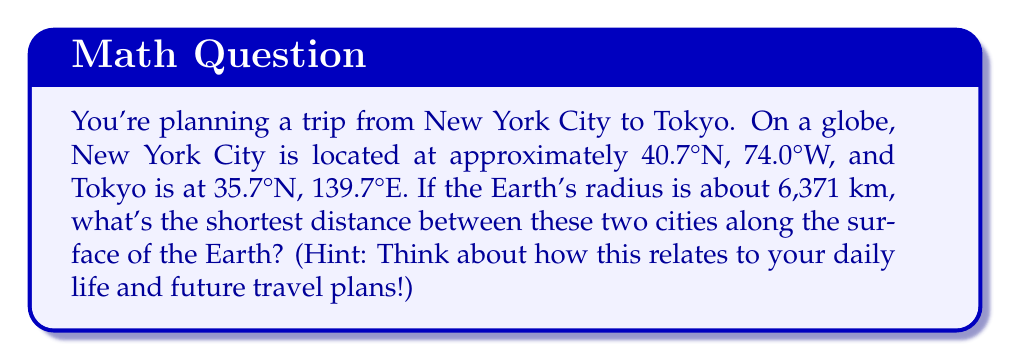Teach me how to tackle this problem. Let's approach this step-by-step:

1) The shortest path between two points on a sphere is along a great circle, which is the intersection of the sphere with a plane passing through the center of the sphere and both points.

2) To find the distance along this great circle, we need to calculate the central angle between the two points and then use the arc length formula.

3) We can use the spherical law of cosines to find the central angle $\theta$:

   $$\cos(\theta) = \sin(\phi_1)\sin(\phi_2) + \cos(\phi_1)\cos(\phi_2)\cos(\Delta\lambda)$$

   Where $\phi_1$ and $\phi_2$ are the latitudes, and $\Delta\lambda$ is the difference in longitudes.

4) Let's convert our coordinates to radians:
   
   New York: $\phi_1 = 40.7° \times \frac{\pi}{180} = 0.7101$ radians
   Tokyo: $\phi_2 = 35.7° \times \frac{\pi}{180} = 0.6230$ radians
   $\Delta\lambda = (139.7° + 74.0°) \times \frac{\pi}{180} = 3.7265$ radians

5) Now, let's plug these into our formula:

   $$\cos(\theta) = \sin(0.7101)\sin(0.6230) + \cos(0.7101)\cos(0.6230)\cos(3.7265)$$

6) Calculating this (you can use a calculator):

   $$\cos(\theta) = 0.1488$$

7) Taking the inverse cosine:

   $$\theta = \arccos(0.1488) = 1.4205 \text{ radians}$$

8) Now that we have the central angle, we can use the arc length formula:

   $$d = r\theta$$

   Where $r$ is the radius of the Earth (6,371 km) and $\theta$ is in radians.

9) Plugging in our values:

   $$d = 6371 \times 1.4205 = 9049.7 \text{ km}$$

This distance represents the shortest path along the surface of the Earth between New York City and Tokyo.
Answer: 9049.7 km 